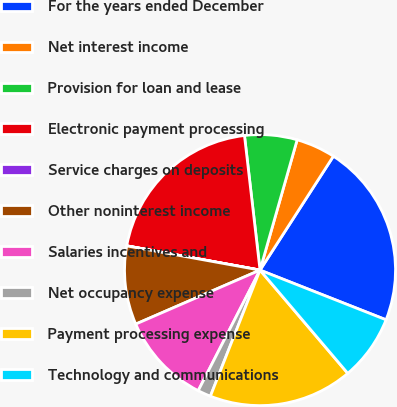Convert chart to OTSL. <chart><loc_0><loc_0><loc_500><loc_500><pie_chart><fcel>For the years ended December<fcel>Net interest income<fcel>Provision for loan and lease<fcel>Electronic payment processing<fcel>Service charges on deposits<fcel>Other noninterest income<fcel>Salaries incentives and<fcel>Net occupancy expense<fcel>Payment processing expense<fcel>Technology and communications<nl><fcel>21.87%<fcel>4.69%<fcel>6.25%<fcel>20.3%<fcel>0.01%<fcel>9.38%<fcel>10.94%<fcel>1.57%<fcel>17.18%<fcel>7.81%<nl></chart> 